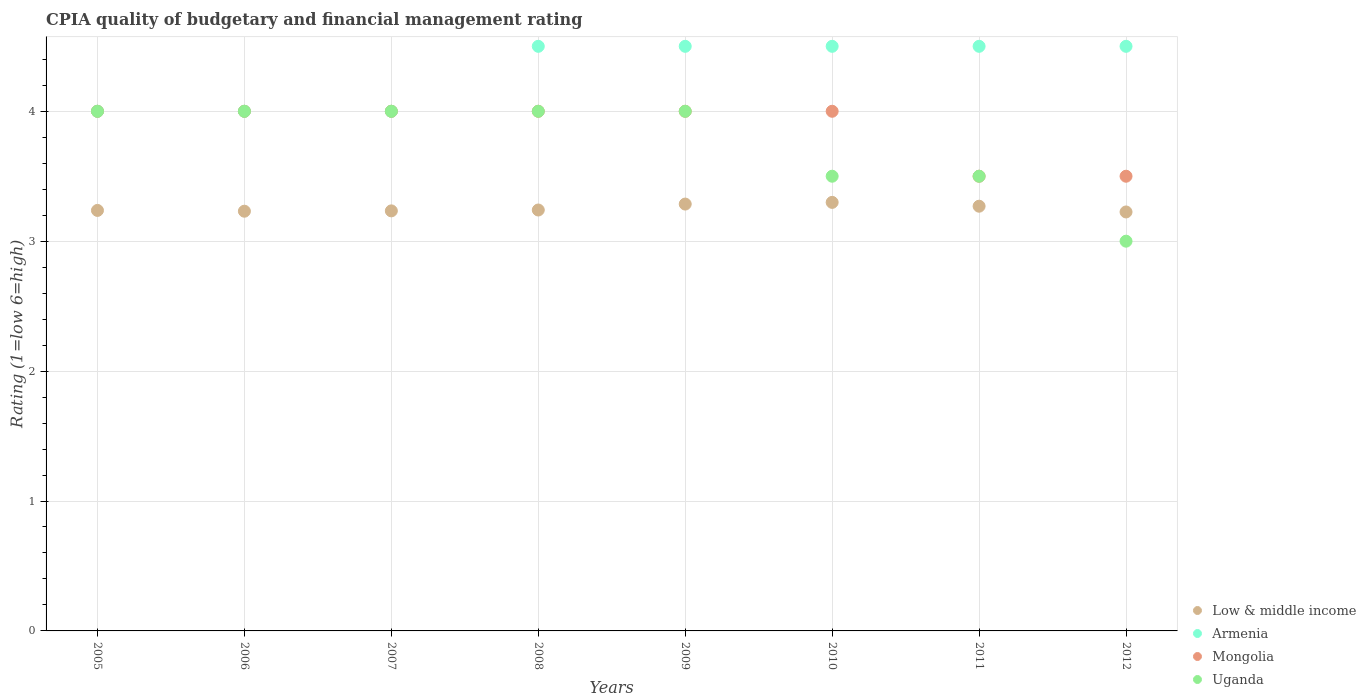What is the CPIA rating in Armenia in 2009?
Your response must be concise. 4.5. Across all years, what is the maximum CPIA rating in Armenia?
Your answer should be compact. 4.5. Across all years, what is the minimum CPIA rating in Armenia?
Offer a very short reply. 4. In which year was the CPIA rating in Armenia maximum?
Your response must be concise. 2008. What is the total CPIA rating in Low & middle income in the graph?
Your response must be concise. 26.02. What is the average CPIA rating in Armenia per year?
Give a very brief answer. 4.31. In the year 2009, what is the difference between the CPIA rating in Low & middle income and CPIA rating in Armenia?
Keep it short and to the point. -1.21. In how many years, is the CPIA rating in Low & middle income greater than 0.2?
Your response must be concise. 8. What is the ratio of the CPIA rating in Armenia in 2006 to that in 2009?
Provide a succinct answer. 0.89. Is the CPIA rating in Low & middle income in 2007 less than that in 2009?
Provide a short and direct response. Yes. What is the difference between the highest and the second highest CPIA rating in Armenia?
Give a very brief answer. 0. What is the difference between the highest and the lowest CPIA rating in Uganda?
Provide a short and direct response. 1. Is the sum of the CPIA rating in Mongolia in 2005 and 2006 greater than the maximum CPIA rating in Low & middle income across all years?
Offer a very short reply. Yes. Is the CPIA rating in Uganda strictly greater than the CPIA rating in Low & middle income over the years?
Provide a short and direct response. No. How many dotlines are there?
Keep it short and to the point. 4. What is the difference between two consecutive major ticks on the Y-axis?
Provide a short and direct response. 1. How are the legend labels stacked?
Your response must be concise. Vertical. What is the title of the graph?
Offer a very short reply. CPIA quality of budgetary and financial management rating. Does "Guinea" appear as one of the legend labels in the graph?
Your response must be concise. No. What is the label or title of the Y-axis?
Ensure brevity in your answer.  Rating (1=low 6=high). What is the Rating (1=low 6=high) of Low & middle income in 2005?
Make the answer very short. 3.24. What is the Rating (1=low 6=high) of Armenia in 2005?
Provide a short and direct response. 4. What is the Rating (1=low 6=high) in Mongolia in 2005?
Offer a very short reply. 4. What is the Rating (1=low 6=high) in Low & middle income in 2006?
Provide a short and direct response. 3.23. What is the Rating (1=low 6=high) in Low & middle income in 2007?
Offer a terse response. 3.23. What is the Rating (1=low 6=high) in Uganda in 2007?
Provide a succinct answer. 4. What is the Rating (1=low 6=high) of Low & middle income in 2008?
Give a very brief answer. 3.24. What is the Rating (1=low 6=high) in Low & middle income in 2009?
Offer a terse response. 3.29. What is the Rating (1=low 6=high) in Low & middle income in 2010?
Make the answer very short. 3.3. What is the Rating (1=low 6=high) in Low & middle income in 2011?
Your response must be concise. 3.27. What is the Rating (1=low 6=high) in Low & middle income in 2012?
Provide a short and direct response. 3.23. What is the Rating (1=low 6=high) in Armenia in 2012?
Ensure brevity in your answer.  4.5. What is the Rating (1=low 6=high) in Mongolia in 2012?
Ensure brevity in your answer.  3.5. Across all years, what is the maximum Rating (1=low 6=high) in Low & middle income?
Provide a short and direct response. 3.3. Across all years, what is the maximum Rating (1=low 6=high) of Armenia?
Ensure brevity in your answer.  4.5. Across all years, what is the minimum Rating (1=low 6=high) in Low & middle income?
Your response must be concise. 3.23. Across all years, what is the minimum Rating (1=low 6=high) of Armenia?
Provide a succinct answer. 4. Across all years, what is the minimum Rating (1=low 6=high) in Mongolia?
Provide a succinct answer. 3.5. Across all years, what is the minimum Rating (1=low 6=high) of Uganda?
Your answer should be compact. 3. What is the total Rating (1=low 6=high) in Low & middle income in the graph?
Keep it short and to the point. 26.02. What is the total Rating (1=low 6=high) of Armenia in the graph?
Make the answer very short. 34.5. What is the difference between the Rating (1=low 6=high) in Low & middle income in 2005 and that in 2006?
Your response must be concise. 0.01. What is the difference between the Rating (1=low 6=high) of Armenia in 2005 and that in 2006?
Make the answer very short. 0. What is the difference between the Rating (1=low 6=high) in Low & middle income in 2005 and that in 2007?
Make the answer very short. 0. What is the difference between the Rating (1=low 6=high) of Armenia in 2005 and that in 2007?
Provide a short and direct response. 0. What is the difference between the Rating (1=low 6=high) in Low & middle income in 2005 and that in 2008?
Keep it short and to the point. -0. What is the difference between the Rating (1=low 6=high) in Armenia in 2005 and that in 2008?
Provide a succinct answer. -0.5. What is the difference between the Rating (1=low 6=high) of Uganda in 2005 and that in 2008?
Make the answer very short. 0. What is the difference between the Rating (1=low 6=high) in Low & middle income in 2005 and that in 2009?
Keep it short and to the point. -0.05. What is the difference between the Rating (1=low 6=high) of Armenia in 2005 and that in 2009?
Provide a short and direct response. -0.5. What is the difference between the Rating (1=low 6=high) of Low & middle income in 2005 and that in 2010?
Ensure brevity in your answer.  -0.06. What is the difference between the Rating (1=low 6=high) of Low & middle income in 2005 and that in 2011?
Your answer should be very brief. -0.03. What is the difference between the Rating (1=low 6=high) in Low & middle income in 2005 and that in 2012?
Offer a terse response. 0.01. What is the difference between the Rating (1=low 6=high) of Mongolia in 2005 and that in 2012?
Your answer should be very brief. 0.5. What is the difference between the Rating (1=low 6=high) of Uganda in 2005 and that in 2012?
Your answer should be very brief. 1. What is the difference between the Rating (1=low 6=high) in Low & middle income in 2006 and that in 2007?
Your response must be concise. -0. What is the difference between the Rating (1=low 6=high) in Armenia in 2006 and that in 2007?
Make the answer very short. 0. What is the difference between the Rating (1=low 6=high) in Low & middle income in 2006 and that in 2008?
Provide a short and direct response. -0.01. What is the difference between the Rating (1=low 6=high) of Uganda in 2006 and that in 2008?
Offer a very short reply. 0. What is the difference between the Rating (1=low 6=high) of Low & middle income in 2006 and that in 2009?
Give a very brief answer. -0.05. What is the difference between the Rating (1=low 6=high) in Mongolia in 2006 and that in 2009?
Make the answer very short. 0. What is the difference between the Rating (1=low 6=high) in Uganda in 2006 and that in 2009?
Offer a very short reply. 0. What is the difference between the Rating (1=low 6=high) in Low & middle income in 2006 and that in 2010?
Your response must be concise. -0.07. What is the difference between the Rating (1=low 6=high) of Low & middle income in 2006 and that in 2011?
Provide a succinct answer. -0.04. What is the difference between the Rating (1=low 6=high) in Armenia in 2006 and that in 2011?
Keep it short and to the point. -0.5. What is the difference between the Rating (1=low 6=high) of Mongolia in 2006 and that in 2011?
Keep it short and to the point. 0.5. What is the difference between the Rating (1=low 6=high) in Uganda in 2006 and that in 2011?
Your answer should be compact. 0.5. What is the difference between the Rating (1=low 6=high) in Low & middle income in 2006 and that in 2012?
Provide a short and direct response. 0.01. What is the difference between the Rating (1=low 6=high) of Uganda in 2006 and that in 2012?
Make the answer very short. 1. What is the difference between the Rating (1=low 6=high) in Low & middle income in 2007 and that in 2008?
Make the answer very short. -0.01. What is the difference between the Rating (1=low 6=high) in Armenia in 2007 and that in 2008?
Keep it short and to the point. -0.5. What is the difference between the Rating (1=low 6=high) in Mongolia in 2007 and that in 2008?
Your answer should be very brief. 0. What is the difference between the Rating (1=low 6=high) of Uganda in 2007 and that in 2008?
Offer a terse response. 0. What is the difference between the Rating (1=low 6=high) of Low & middle income in 2007 and that in 2009?
Your response must be concise. -0.05. What is the difference between the Rating (1=low 6=high) in Low & middle income in 2007 and that in 2010?
Provide a short and direct response. -0.07. What is the difference between the Rating (1=low 6=high) of Armenia in 2007 and that in 2010?
Your answer should be very brief. -0.5. What is the difference between the Rating (1=low 6=high) of Mongolia in 2007 and that in 2010?
Your answer should be very brief. 0. What is the difference between the Rating (1=low 6=high) of Uganda in 2007 and that in 2010?
Your answer should be compact. 0.5. What is the difference between the Rating (1=low 6=high) of Low & middle income in 2007 and that in 2011?
Ensure brevity in your answer.  -0.04. What is the difference between the Rating (1=low 6=high) in Armenia in 2007 and that in 2011?
Your response must be concise. -0.5. What is the difference between the Rating (1=low 6=high) in Uganda in 2007 and that in 2011?
Your response must be concise. 0.5. What is the difference between the Rating (1=low 6=high) in Low & middle income in 2007 and that in 2012?
Your answer should be compact. 0.01. What is the difference between the Rating (1=low 6=high) in Uganda in 2007 and that in 2012?
Keep it short and to the point. 1. What is the difference between the Rating (1=low 6=high) of Low & middle income in 2008 and that in 2009?
Keep it short and to the point. -0.05. What is the difference between the Rating (1=low 6=high) in Low & middle income in 2008 and that in 2010?
Your answer should be compact. -0.06. What is the difference between the Rating (1=low 6=high) in Uganda in 2008 and that in 2010?
Make the answer very short. 0.5. What is the difference between the Rating (1=low 6=high) of Low & middle income in 2008 and that in 2011?
Ensure brevity in your answer.  -0.03. What is the difference between the Rating (1=low 6=high) in Armenia in 2008 and that in 2011?
Provide a short and direct response. 0. What is the difference between the Rating (1=low 6=high) in Uganda in 2008 and that in 2011?
Your answer should be very brief. 0.5. What is the difference between the Rating (1=low 6=high) of Low & middle income in 2008 and that in 2012?
Offer a terse response. 0.01. What is the difference between the Rating (1=low 6=high) of Mongolia in 2008 and that in 2012?
Ensure brevity in your answer.  0.5. What is the difference between the Rating (1=low 6=high) in Uganda in 2008 and that in 2012?
Your answer should be very brief. 1. What is the difference between the Rating (1=low 6=high) of Low & middle income in 2009 and that in 2010?
Provide a succinct answer. -0.01. What is the difference between the Rating (1=low 6=high) in Armenia in 2009 and that in 2010?
Your answer should be compact. 0. What is the difference between the Rating (1=low 6=high) of Low & middle income in 2009 and that in 2011?
Your answer should be very brief. 0.02. What is the difference between the Rating (1=low 6=high) in Armenia in 2009 and that in 2011?
Provide a short and direct response. 0. What is the difference between the Rating (1=low 6=high) of Uganda in 2009 and that in 2011?
Ensure brevity in your answer.  0.5. What is the difference between the Rating (1=low 6=high) in Low & middle income in 2009 and that in 2012?
Give a very brief answer. 0.06. What is the difference between the Rating (1=low 6=high) of Armenia in 2009 and that in 2012?
Make the answer very short. 0. What is the difference between the Rating (1=low 6=high) in Uganda in 2009 and that in 2012?
Provide a succinct answer. 1. What is the difference between the Rating (1=low 6=high) of Low & middle income in 2010 and that in 2011?
Make the answer very short. 0.03. What is the difference between the Rating (1=low 6=high) of Mongolia in 2010 and that in 2011?
Give a very brief answer. 0.5. What is the difference between the Rating (1=low 6=high) in Low & middle income in 2010 and that in 2012?
Make the answer very short. 0.07. What is the difference between the Rating (1=low 6=high) of Armenia in 2010 and that in 2012?
Provide a short and direct response. 0. What is the difference between the Rating (1=low 6=high) in Low & middle income in 2011 and that in 2012?
Give a very brief answer. 0.04. What is the difference between the Rating (1=low 6=high) in Armenia in 2011 and that in 2012?
Your response must be concise. 0. What is the difference between the Rating (1=low 6=high) in Mongolia in 2011 and that in 2012?
Provide a succinct answer. 0. What is the difference between the Rating (1=low 6=high) of Low & middle income in 2005 and the Rating (1=low 6=high) of Armenia in 2006?
Provide a succinct answer. -0.76. What is the difference between the Rating (1=low 6=high) of Low & middle income in 2005 and the Rating (1=low 6=high) of Mongolia in 2006?
Keep it short and to the point. -0.76. What is the difference between the Rating (1=low 6=high) in Low & middle income in 2005 and the Rating (1=low 6=high) in Uganda in 2006?
Offer a terse response. -0.76. What is the difference between the Rating (1=low 6=high) of Armenia in 2005 and the Rating (1=low 6=high) of Mongolia in 2006?
Your response must be concise. 0. What is the difference between the Rating (1=low 6=high) in Low & middle income in 2005 and the Rating (1=low 6=high) in Armenia in 2007?
Provide a succinct answer. -0.76. What is the difference between the Rating (1=low 6=high) of Low & middle income in 2005 and the Rating (1=low 6=high) of Mongolia in 2007?
Provide a succinct answer. -0.76. What is the difference between the Rating (1=low 6=high) of Low & middle income in 2005 and the Rating (1=low 6=high) of Uganda in 2007?
Your response must be concise. -0.76. What is the difference between the Rating (1=low 6=high) of Low & middle income in 2005 and the Rating (1=low 6=high) of Armenia in 2008?
Your answer should be very brief. -1.26. What is the difference between the Rating (1=low 6=high) in Low & middle income in 2005 and the Rating (1=low 6=high) in Mongolia in 2008?
Offer a very short reply. -0.76. What is the difference between the Rating (1=low 6=high) of Low & middle income in 2005 and the Rating (1=low 6=high) of Uganda in 2008?
Provide a short and direct response. -0.76. What is the difference between the Rating (1=low 6=high) of Mongolia in 2005 and the Rating (1=low 6=high) of Uganda in 2008?
Offer a very short reply. 0. What is the difference between the Rating (1=low 6=high) of Low & middle income in 2005 and the Rating (1=low 6=high) of Armenia in 2009?
Keep it short and to the point. -1.26. What is the difference between the Rating (1=low 6=high) of Low & middle income in 2005 and the Rating (1=low 6=high) of Mongolia in 2009?
Your answer should be very brief. -0.76. What is the difference between the Rating (1=low 6=high) in Low & middle income in 2005 and the Rating (1=low 6=high) in Uganda in 2009?
Offer a very short reply. -0.76. What is the difference between the Rating (1=low 6=high) in Armenia in 2005 and the Rating (1=low 6=high) in Mongolia in 2009?
Your answer should be very brief. 0. What is the difference between the Rating (1=low 6=high) in Low & middle income in 2005 and the Rating (1=low 6=high) in Armenia in 2010?
Give a very brief answer. -1.26. What is the difference between the Rating (1=low 6=high) of Low & middle income in 2005 and the Rating (1=low 6=high) of Mongolia in 2010?
Your answer should be compact. -0.76. What is the difference between the Rating (1=low 6=high) of Low & middle income in 2005 and the Rating (1=low 6=high) of Uganda in 2010?
Provide a succinct answer. -0.26. What is the difference between the Rating (1=low 6=high) of Mongolia in 2005 and the Rating (1=low 6=high) of Uganda in 2010?
Offer a terse response. 0.5. What is the difference between the Rating (1=low 6=high) of Low & middle income in 2005 and the Rating (1=low 6=high) of Armenia in 2011?
Provide a succinct answer. -1.26. What is the difference between the Rating (1=low 6=high) in Low & middle income in 2005 and the Rating (1=low 6=high) in Mongolia in 2011?
Keep it short and to the point. -0.26. What is the difference between the Rating (1=low 6=high) of Low & middle income in 2005 and the Rating (1=low 6=high) of Uganda in 2011?
Your answer should be compact. -0.26. What is the difference between the Rating (1=low 6=high) in Mongolia in 2005 and the Rating (1=low 6=high) in Uganda in 2011?
Your answer should be very brief. 0.5. What is the difference between the Rating (1=low 6=high) in Low & middle income in 2005 and the Rating (1=low 6=high) in Armenia in 2012?
Your answer should be very brief. -1.26. What is the difference between the Rating (1=low 6=high) of Low & middle income in 2005 and the Rating (1=low 6=high) of Mongolia in 2012?
Offer a very short reply. -0.26. What is the difference between the Rating (1=low 6=high) of Low & middle income in 2005 and the Rating (1=low 6=high) of Uganda in 2012?
Ensure brevity in your answer.  0.24. What is the difference between the Rating (1=low 6=high) of Armenia in 2005 and the Rating (1=low 6=high) of Mongolia in 2012?
Make the answer very short. 0.5. What is the difference between the Rating (1=low 6=high) of Low & middle income in 2006 and the Rating (1=low 6=high) of Armenia in 2007?
Provide a short and direct response. -0.77. What is the difference between the Rating (1=low 6=high) of Low & middle income in 2006 and the Rating (1=low 6=high) of Mongolia in 2007?
Provide a short and direct response. -0.77. What is the difference between the Rating (1=low 6=high) of Low & middle income in 2006 and the Rating (1=low 6=high) of Uganda in 2007?
Your answer should be compact. -0.77. What is the difference between the Rating (1=low 6=high) of Mongolia in 2006 and the Rating (1=low 6=high) of Uganda in 2007?
Keep it short and to the point. 0. What is the difference between the Rating (1=low 6=high) of Low & middle income in 2006 and the Rating (1=low 6=high) of Armenia in 2008?
Ensure brevity in your answer.  -1.27. What is the difference between the Rating (1=low 6=high) of Low & middle income in 2006 and the Rating (1=low 6=high) of Mongolia in 2008?
Give a very brief answer. -0.77. What is the difference between the Rating (1=low 6=high) in Low & middle income in 2006 and the Rating (1=low 6=high) in Uganda in 2008?
Your answer should be very brief. -0.77. What is the difference between the Rating (1=low 6=high) in Mongolia in 2006 and the Rating (1=low 6=high) in Uganda in 2008?
Provide a succinct answer. 0. What is the difference between the Rating (1=low 6=high) in Low & middle income in 2006 and the Rating (1=low 6=high) in Armenia in 2009?
Give a very brief answer. -1.27. What is the difference between the Rating (1=low 6=high) in Low & middle income in 2006 and the Rating (1=low 6=high) in Mongolia in 2009?
Offer a very short reply. -0.77. What is the difference between the Rating (1=low 6=high) of Low & middle income in 2006 and the Rating (1=low 6=high) of Uganda in 2009?
Your answer should be compact. -0.77. What is the difference between the Rating (1=low 6=high) in Armenia in 2006 and the Rating (1=low 6=high) in Uganda in 2009?
Your answer should be compact. 0. What is the difference between the Rating (1=low 6=high) of Low & middle income in 2006 and the Rating (1=low 6=high) of Armenia in 2010?
Offer a terse response. -1.27. What is the difference between the Rating (1=low 6=high) in Low & middle income in 2006 and the Rating (1=low 6=high) in Mongolia in 2010?
Keep it short and to the point. -0.77. What is the difference between the Rating (1=low 6=high) in Low & middle income in 2006 and the Rating (1=low 6=high) in Uganda in 2010?
Ensure brevity in your answer.  -0.27. What is the difference between the Rating (1=low 6=high) in Armenia in 2006 and the Rating (1=low 6=high) in Uganda in 2010?
Give a very brief answer. 0.5. What is the difference between the Rating (1=low 6=high) of Mongolia in 2006 and the Rating (1=low 6=high) of Uganda in 2010?
Your answer should be very brief. 0.5. What is the difference between the Rating (1=low 6=high) in Low & middle income in 2006 and the Rating (1=low 6=high) in Armenia in 2011?
Ensure brevity in your answer.  -1.27. What is the difference between the Rating (1=low 6=high) of Low & middle income in 2006 and the Rating (1=low 6=high) of Mongolia in 2011?
Offer a very short reply. -0.27. What is the difference between the Rating (1=low 6=high) in Low & middle income in 2006 and the Rating (1=low 6=high) in Uganda in 2011?
Provide a succinct answer. -0.27. What is the difference between the Rating (1=low 6=high) of Mongolia in 2006 and the Rating (1=low 6=high) of Uganda in 2011?
Ensure brevity in your answer.  0.5. What is the difference between the Rating (1=low 6=high) of Low & middle income in 2006 and the Rating (1=low 6=high) of Armenia in 2012?
Provide a short and direct response. -1.27. What is the difference between the Rating (1=low 6=high) of Low & middle income in 2006 and the Rating (1=low 6=high) of Mongolia in 2012?
Give a very brief answer. -0.27. What is the difference between the Rating (1=low 6=high) of Low & middle income in 2006 and the Rating (1=low 6=high) of Uganda in 2012?
Your response must be concise. 0.23. What is the difference between the Rating (1=low 6=high) in Low & middle income in 2007 and the Rating (1=low 6=high) in Armenia in 2008?
Give a very brief answer. -1.27. What is the difference between the Rating (1=low 6=high) of Low & middle income in 2007 and the Rating (1=low 6=high) of Mongolia in 2008?
Your response must be concise. -0.77. What is the difference between the Rating (1=low 6=high) in Low & middle income in 2007 and the Rating (1=low 6=high) in Uganda in 2008?
Offer a very short reply. -0.77. What is the difference between the Rating (1=low 6=high) of Low & middle income in 2007 and the Rating (1=low 6=high) of Armenia in 2009?
Provide a short and direct response. -1.27. What is the difference between the Rating (1=low 6=high) of Low & middle income in 2007 and the Rating (1=low 6=high) of Mongolia in 2009?
Offer a very short reply. -0.77. What is the difference between the Rating (1=low 6=high) in Low & middle income in 2007 and the Rating (1=low 6=high) in Uganda in 2009?
Your answer should be very brief. -0.77. What is the difference between the Rating (1=low 6=high) of Armenia in 2007 and the Rating (1=low 6=high) of Mongolia in 2009?
Make the answer very short. 0. What is the difference between the Rating (1=low 6=high) of Armenia in 2007 and the Rating (1=low 6=high) of Uganda in 2009?
Keep it short and to the point. 0. What is the difference between the Rating (1=low 6=high) in Mongolia in 2007 and the Rating (1=low 6=high) in Uganda in 2009?
Make the answer very short. 0. What is the difference between the Rating (1=low 6=high) in Low & middle income in 2007 and the Rating (1=low 6=high) in Armenia in 2010?
Ensure brevity in your answer.  -1.27. What is the difference between the Rating (1=low 6=high) of Low & middle income in 2007 and the Rating (1=low 6=high) of Mongolia in 2010?
Your answer should be compact. -0.77. What is the difference between the Rating (1=low 6=high) in Low & middle income in 2007 and the Rating (1=low 6=high) in Uganda in 2010?
Your response must be concise. -0.27. What is the difference between the Rating (1=low 6=high) in Armenia in 2007 and the Rating (1=low 6=high) in Mongolia in 2010?
Give a very brief answer. 0. What is the difference between the Rating (1=low 6=high) in Armenia in 2007 and the Rating (1=low 6=high) in Uganda in 2010?
Make the answer very short. 0.5. What is the difference between the Rating (1=low 6=high) of Mongolia in 2007 and the Rating (1=low 6=high) of Uganda in 2010?
Offer a terse response. 0.5. What is the difference between the Rating (1=low 6=high) of Low & middle income in 2007 and the Rating (1=low 6=high) of Armenia in 2011?
Make the answer very short. -1.27. What is the difference between the Rating (1=low 6=high) of Low & middle income in 2007 and the Rating (1=low 6=high) of Mongolia in 2011?
Provide a succinct answer. -0.27. What is the difference between the Rating (1=low 6=high) in Low & middle income in 2007 and the Rating (1=low 6=high) in Uganda in 2011?
Provide a short and direct response. -0.27. What is the difference between the Rating (1=low 6=high) of Armenia in 2007 and the Rating (1=low 6=high) of Mongolia in 2011?
Offer a very short reply. 0.5. What is the difference between the Rating (1=low 6=high) of Mongolia in 2007 and the Rating (1=low 6=high) of Uganda in 2011?
Keep it short and to the point. 0.5. What is the difference between the Rating (1=low 6=high) in Low & middle income in 2007 and the Rating (1=low 6=high) in Armenia in 2012?
Offer a terse response. -1.27. What is the difference between the Rating (1=low 6=high) of Low & middle income in 2007 and the Rating (1=low 6=high) of Mongolia in 2012?
Keep it short and to the point. -0.27. What is the difference between the Rating (1=low 6=high) in Low & middle income in 2007 and the Rating (1=low 6=high) in Uganda in 2012?
Your response must be concise. 0.23. What is the difference between the Rating (1=low 6=high) in Armenia in 2007 and the Rating (1=low 6=high) in Uganda in 2012?
Your answer should be compact. 1. What is the difference between the Rating (1=low 6=high) of Low & middle income in 2008 and the Rating (1=low 6=high) of Armenia in 2009?
Your response must be concise. -1.26. What is the difference between the Rating (1=low 6=high) of Low & middle income in 2008 and the Rating (1=low 6=high) of Mongolia in 2009?
Provide a short and direct response. -0.76. What is the difference between the Rating (1=low 6=high) of Low & middle income in 2008 and the Rating (1=low 6=high) of Uganda in 2009?
Offer a very short reply. -0.76. What is the difference between the Rating (1=low 6=high) in Low & middle income in 2008 and the Rating (1=low 6=high) in Armenia in 2010?
Offer a very short reply. -1.26. What is the difference between the Rating (1=low 6=high) in Low & middle income in 2008 and the Rating (1=low 6=high) in Mongolia in 2010?
Ensure brevity in your answer.  -0.76. What is the difference between the Rating (1=low 6=high) in Low & middle income in 2008 and the Rating (1=low 6=high) in Uganda in 2010?
Make the answer very short. -0.26. What is the difference between the Rating (1=low 6=high) in Armenia in 2008 and the Rating (1=low 6=high) in Mongolia in 2010?
Your response must be concise. 0.5. What is the difference between the Rating (1=low 6=high) of Low & middle income in 2008 and the Rating (1=low 6=high) of Armenia in 2011?
Keep it short and to the point. -1.26. What is the difference between the Rating (1=low 6=high) of Low & middle income in 2008 and the Rating (1=low 6=high) of Mongolia in 2011?
Provide a succinct answer. -0.26. What is the difference between the Rating (1=low 6=high) in Low & middle income in 2008 and the Rating (1=low 6=high) in Uganda in 2011?
Offer a terse response. -0.26. What is the difference between the Rating (1=low 6=high) of Mongolia in 2008 and the Rating (1=low 6=high) of Uganda in 2011?
Ensure brevity in your answer.  0.5. What is the difference between the Rating (1=low 6=high) in Low & middle income in 2008 and the Rating (1=low 6=high) in Armenia in 2012?
Make the answer very short. -1.26. What is the difference between the Rating (1=low 6=high) in Low & middle income in 2008 and the Rating (1=low 6=high) in Mongolia in 2012?
Provide a short and direct response. -0.26. What is the difference between the Rating (1=low 6=high) of Low & middle income in 2008 and the Rating (1=low 6=high) of Uganda in 2012?
Provide a succinct answer. 0.24. What is the difference between the Rating (1=low 6=high) of Mongolia in 2008 and the Rating (1=low 6=high) of Uganda in 2012?
Offer a terse response. 1. What is the difference between the Rating (1=low 6=high) of Low & middle income in 2009 and the Rating (1=low 6=high) of Armenia in 2010?
Ensure brevity in your answer.  -1.21. What is the difference between the Rating (1=low 6=high) in Low & middle income in 2009 and the Rating (1=low 6=high) in Mongolia in 2010?
Your response must be concise. -0.71. What is the difference between the Rating (1=low 6=high) in Low & middle income in 2009 and the Rating (1=low 6=high) in Uganda in 2010?
Offer a terse response. -0.21. What is the difference between the Rating (1=low 6=high) in Armenia in 2009 and the Rating (1=low 6=high) in Mongolia in 2010?
Give a very brief answer. 0.5. What is the difference between the Rating (1=low 6=high) in Armenia in 2009 and the Rating (1=low 6=high) in Uganda in 2010?
Provide a short and direct response. 1. What is the difference between the Rating (1=low 6=high) of Low & middle income in 2009 and the Rating (1=low 6=high) of Armenia in 2011?
Your answer should be very brief. -1.21. What is the difference between the Rating (1=low 6=high) of Low & middle income in 2009 and the Rating (1=low 6=high) of Mongolia in 2011?
Provide a short and direct response. -0.21. What is the difference between the Rating (1=low 6=high) of Low & middle income in 2009 and the Rating (1=low 6=high) of Uganda in 2011?
Keep it short and to the point. -0.21. What is the difference between the Rating (1=low 6=high) of Low & middle income in 2009 and the Rating (1=low 6=high) of Armenia in 2012?
Keep it short and to the point. -1.21. What is the difference between the Rating (1=low 6=high) in Low & middle income in 2009 and the Rating (1=low 6=high) in Mongolia in 2012?
Offer a terse response. -0.21. What is the difference between the Rating (1=low 6=high) of Low & middle income in 2009 and the Rating (1=low 6=high) of Uganda in 2012?
Provide a short and direct response. 0.29. What is the difference between the Rating (1=low 6=high) of Armenia in 2009 and the Rating (1=low 6=high) of Mongolia in 2012?
Your answer should be very brief. 1. What is the difference between the Rating (1=low 6=high) of Low & middle income in 2010 and the Rating (1=low 6=high) of Armenia in 2011?
Offer a terse response. -1.2. What is the difference between the Rating (1=low 6=high) in Low & middle income in 2010 and the Rating (1=low 6=high) in Mongolia in 2011?
Give a very brief answer. -0.2. What is the difference between the Rating (1=low 6=high) of Low & middle income in 2010 and the Rating (1=low 6=high) of Uganda in 2011?
Offer a terse response. -0.2. What is the difference between the Rating (1=low 6=high) in Armenia in 2010 and the Rating (1=low 6=high) in Mongolia in 2011?
Provide a short and direct response. 1. What is the difference between the Rating (1=low 6=high) of Armenia in 2010 and the Rating (1=low 6=high) of Uganda in 2011?
Keep it short and to the point. 1. What is the difference between the Rating (1=low 6=high) of Low & middle income in 2010 and the Rating (1=low 6=high) of Armenia in 2012?
Provide a succinct answer. -1.2. What is the difference between the Rating (1=low 6=high) in Low & middle income in 2010 and the Rating (1=low 6=high) in Mongolia in 2012?
Provide a short and direct response. -0.2. What is the difference between the Rating (1=low 6=high) in Low & middle income in 2010 and the Rating (1=low 6=high) in Uganda in 2012?
Your answer should be compact. 0.3. What is the difference between the Rating (1=low 6=high) in Armenia in 2010 and the Rating (1=low 6=high) in Mongolia in 2012?
Your response must be concise. 1. What is the difference between the Rating (1=low 6=high) of Mongolia in 2010 and the Rating (1=low 6=high) of Uganda in 2012?
Give a very brief answer. 1. What is the difference between the Rating (1=low 6=high) of Low & middle income in 2011 and the Rating (1=low 6=high) of Armenia in 2012?
Provide a short and direct response. -1.23. What is the difference between the Rating (1=low 6=high) in Low & middle income in 2011 and the Rating (1=low 6=high) in Mongolia in 2012?
Your answer should be compact. -0.23. What is the difference between the Rating (1=low 6=high) of Low & middle income in 2011 and the Rating (1=low 6=high) of Uganda in 2012?
Provide a short and direct response. 0.27. What is the difference between the Rating (1=low 6=high) in Armenia in 2011 and the Rating (1=low 6=high) in Mongolia in 2012?
Your response must be concise. 1. What is the difference between the Rating (1=low 6=high) of Mongolia in 2011 and the Rating (1=low 6=high) of Uganda in 2012?
Keep it short and to the point. 0.5. What is the average Rating (1=low 6=high) in Low & middle income per year?
Your response must be concise. 3.25. What is the average Rating (1=low 6=high) of Armenia per year?
Your answer should be compact. 4.31. What is the average Rating (1=low 6=high) in Mongolia per year?
Keep it short and to the point. 3.88. What is the average Rating (1=low 6=high) in Uganda per year?
Offer a terse response. 3.75. In the year 2005, what is the difference between the Rating (1=low 6=high) of Low & middle income and Rating (1=low 6=high) of Armenia?
Offer a very short reply. -0.76. In the year 2005, what is the difference between the Rating (1=low 6=high) in Low & middle income and Rating (1=low 6=high) in Mongolia?
Offer a very short reply. -0.76. In the year 2005, what is the difference between the Rating (1=low 6=high) of Low & middle income and Rating (1=low 6=high) of Uganda?
Give a very brief answer. -0.76. In the year 2005, what is the difference between the Rating (1=low 6=high) of Armenia and Rating (1=low 6=high) of Mongolia?
Your answer should be very brief. 0. In the year 2006, what is the difference between the Rating (1=low 6=high) in Low & middle income and Rating (1=low 6=high) in Armenia?
Your answer should be very brief. -0.77. In the year 2006, what is the difference between the Rating (1=low 6=high) in Low & middle income and Rating (1=low 6=high) in Mongolia?
Offer a terse response. -0.77. In the year 2006, what is the difference between the Rating (1=low 6=high) in Low & middle income and Rating (1=low 6=high) in Uganda?
Your answer should be compact. -0.77. In the year 2006, what is the difference between the Rating (1=low 6=high) in Mongolia and Rating (1=low 6=high) in Uganda?
Make the answer very short. 0. In the year 2007, what is the difference between the Rating (1=low 6=high) of Low & middle income and Rating (1=low 6=high) of Armenia?
Your answer should be compact. -0.77. In the year 2007, what is the difference between the Rating (1=low 6=high) in Low & middle income and Rating (1=low 6=high) in Mongolia?
Provide a short and direct response. -0.77. In the year 2007, what is the difference between the Rating (1=low 6=high) of Low & middle income and Rating (1=low 6=high) of Uganda?
Offer a terse response. -0.77. In the year 2007, what is the difference between the Rating (1=low 6=high) of Armenia and Rating (1=low 6=high) of Mongolia?
Your answer should be compact. 0. In the year 2007, what is the difference between the Rating (1=low 6=high) in Armenia and Rating (1=low 6=high) in Uganda?
Keep it short and to the point. 0. In the year 2007, what is the difference between the Rating (1=low 6=high) of Mongolia and Rating (1=low 6=high) of Uganda?
Offer a terse response. 0. In the year 2008, what is the difference between the Rating (1=low 6=high) in Low & middle income and Rating (1=low 6=high) in Armenia?
Keep it short and to the point. -1.26. In the year 2008, what is the difference between the Rating (1=low 6=high) in Low & middle income and Rating (1=low 6=high) in Mongolia?
Give a very brief answer. -0.76. In the year 2008, what is the difference between the Rating (1=low 6=high) in Low & middle income and Rating (1=low 6=high) in Uganda?
Make the answer very short. -0.76. In the year 2008, what is the difference between the Rating (1=low 6=high) of Armenia and Rating (1=low 6=high) of Uganda?
Your answer should be very brief. 0.5. In the year 2009, what is the difference between the Rating (1=low 6=high) in Low & middle income and Rating (1=low 6=high) in Armenia?
Ensure brevity in your answer.  -1.21. In the year 2009, what is the difference between the Rating (1=low 6=high) of Low & middle income and Rating (1=low 6=high) of Mongolia?
Keep it short and to the point. -0.71. In the year 2009, what is the difference between the Rating (1=low 6=high) of Low & middle income and Rating (1=low 6=high) of Uganda?
Make the answer very short. -0.71. In the year 2009, what is the difference between the Rating (1=low 6=high) in Armenia and Rating (1=low 6=high) in Uganda?
Keep it short and to the point. 0.5. In the year 2009, what is the difference between the Rating (1=low 6=high) in Mongolia and Rating (1=low 6=high) in Uganda?
Offer a very short reply. 0. In the year 2010, what is the difference between the Rating (1=low 6=high) of Low & middle income and Rating (1=low 6=high) of Armenia?
Provide a succinct answer. -1.2. In the year 2010, what is the difference between the Rating (1=low 6=high) of Low & middle income and Rating (1=low 6=high) of Mongolia?
Make the answer very short. -0.7. In the year 2010, what is the difference between the Rating (1=low 6=high) in Low & middle income and Rating (1=low 6=high) in Uganda?
Your answer should be compact. -0.2. In the year 2010, what is the difference between the Rating (1=low 6=high) of Armenia and Rating (1=low 6=high) of Uganda?
Your answer should be very brief. 1. In the year 2010, what is the difference between the Rating (1=low 6=high) in Mongolia and Rating (1=low 6=high) in Uganda?
Give a very brief answer. 0.5. In the year 2011, what is the difference between the Rating (1=low 6=high) of Low & middle income and Rating (1=low 6=high) of Armenia?
Your answer should be compact. -1.23. In the year 2011, what is the difference between the Rating (1=low 6=high) in Low & middle income and Rating (1=low 6=high) in Mongolia?
Offer a very short reply. -0.23. In the year 2011, what is the difference between the Rating (1=low 6=high) of Low & middle income and Rating (1=low 6=high) of Uganda?
Give a very brief answer. -0.23. In the year 2012, what is the difference between the Rating (1=low 6=high) in Low & middle income and Rating (1=low 6=high) in Armenia?
Your answer should be compact. -1.27. In the year 2012, what is the difference between the Rating (1=low 6=high) of Low & middle income and Rating (1=low 6=high) of Mongolia?
Keep it short and to the point. -0.28. In the year 2012, what is the difference between the Rating (1=low 6=high) of Low & middle income and Rating (1=low 6=high) of Uganda?
Make the answer very short. 0.23. In the year 2012, what is the difference between the Rating (1=low 6=high) of Armenia and Rating (1=low 6=high) of Mongolia?
Provide a short and direct response. 1. In the year 2012, what is the difference between the Rating (1=low 6=high) of Armenia and Rating (1=low 6=high) of Uganda?
Provide a short and direct response. 1.5. What is the ratio of the Rating (1=low 6=high) of Armenia in 2005 to that in 2006?
Your answer should be very brief. 1. What is the ratio of the Rating (1=low 6=high) of Mongolia in 2005 to that in 2006?
Provide a short and direct response. 1. What is the ratio of the Rating (1=low 6=high) of Uganda in 2005 to that in 2006?
Your answer should be compact. 1. What is the ratio of the Rating (1=low 6=high) of Low & middle income in 2005 to that in 2007?
Make the answer very short. 1. What is the ratio of the Rating (1=low 6=high) in Mongolia in 2005 to that in 2007?
Provide a short and direct response. 1. What is the ratio of the Rating (1=low 6=high) of Low & middle income in 2005 to that in 2008?
Provide a short and direct response. 1. What is the ratio of the Rating (1=low 6=high) in Armenia in 2005 to that in 2008?
Make the answer very short. 0.89. What is the ratio of the Rating (1=low 6=high) of Mongolia in 2005 to that in 2008?
Provide a succinct answer. 1. What is the ratio of the Rating (1=low 6=high) in Uganda in 2005 to that in 2008?
Ensure brevity in your answer.  1. What is the ratio of the Rating (1=low 6=high) in Low & middle income in 2005 to that in 2009?
Offer a terse response. 0.99. What is the ratio of the Rating (1=low 6=high) of Low & middle income in 2005 to that in 2010?
Make the answer very short. 0.98. What is the ratio of the Rating (1=low 6=high) in Armenia in 2005 to that in 2010?
Offer a terse response. 0.89. What is the ratio of the Rating (1=low 6=high) in Mongolia in 2005 to that in 2010?
Make the answer very short. 1. What is the ratio of the Rating (1=low 6=high) in Low & middle income in 2005 to that in 2011?
Provide a succinct answer. 0.99. What is the ratio of the Rating (1=low 6=high) in Armenia in 2005 to that in 2011?
Your response must be concise. 0.89. What is the ratio of the Rating (1=low 6=high) of Uganda in 2005 to that in 2011?
Your answer should be very brief. 1.14. What is the ratio of the Rating (1=low 6=high) in Low & middle income in 2005 to that in 2012?
Make the answer very short. 1. What is the ratio of the Rating (1=low 6=high) in Mongolia in 2005 to that in 2012?
Provide a succinct answer. 1.14. What is the ratio of the Rating (1=low 6=high) in Low & middle income in 2006 to that in 2007?
Your answer should be very brief. 1. What is the ratio of the Rating (1=low 6=high) in Armenia in 2006 to that in 2007?
Your answer should be compact. 1. What is the ratio of the Rating (1=low 6=high) of Low & middle income in 2006 to that in 2008?
Give a very brief answer. 1. What is the ratio of the Rating (1=low 6=high) of Armenia in 2006 to that in 2008?
Keep it short and to the point. 0.89. What is the ratio of the Rating (1=low 6=high) in Uganda in 2006 to that in 2008?
Give a very brief answer. 1. What is the ratio of the Rating (1=low 6=high) in Low & middle income in 2006 to that in 2009?
Give a very brief answer. 0.98. What is the ratio of the Rating (1=low 6=high) in Uganda in 2006 to that in 2009?
Your answer should be compact. 1. What is the ratio of the Rating (1=low 6=high) in Low & middle income in 2006 to that in 2010?
Your response must be concise. 0.98. What is the ratio of the Rating (1=low 6=high) of Armenia in 2006 to that in 2011?
Ensure brevity in your answer.  0.89. What is the ratio of the Rating (1=low 6=high) of Mongolia in 2006 to that in 2011?
Offer a terse response. 1.14. What is the ratio of the Rating (1=low 6=high) of Uganda in 2006 to that in 2011?
Your response must be concise. 1.14. What is the ratio of the Rating (1=low 6=high) in Low & middle income in 2006 to that in 2012?
Provide a succinct answer. 1. What is the ratio of the Rating (1=low 6=high) of Low & middle income in 2007 to that in 2008?
Your answer should be very brief. 1. What is the ratio of the Rating (1=low 6=high) in Armenia in 2007 to that in 2008?
Your answer should be compact. 0.89. What is the ratio of the Rating (1=low 6=high) of Mongolia in 2007 to that in 2008?
Provide a short and direct response. 1. What is the ratio of the Rating (1=low 6=high) of Low & middle income in 2007 to that in 2009?
Your response must be concise. 0.98. What is the ratio of the Rating (1=low 6=high) of Armenia in 2007 to that in 2009?
Give a very brief answer. 0.89. What is the ratio of the Rating (1=low 6=high) of Mongolia in 2007 to that in 2009?
Give a very brief answer. 1. What is the ratio of the Rating (1=low 6=high) of Uganda in 2007 to that in 2009?
Provide a succinct answer. 1. What is the ratio of the Rating (1=low 6=high) in Low & middle income in 2007 to that in 2010?
Provide a succinct answer. 0.98. What is the ratio of the Rating (1=low 6=high) in Mongolia in 2007 to that in 2010?
Your answer should be compact. 1. What is the ratio of the Rating (1=low 6=high) in Uganda in 2007 to that in 2010?
Make the answer very short. 1.14. What is the ratio of the Rating (1=low 6=high) of Mongolia in 2007 to that in 2011?
Offer a terse response. 1.14. What is the ratio of the Rating (1=low 6=high) in Low & middle income in 2007 to that in 2012?
Provide a short and direct response. 1. What is the ratio of the Rating (1=low 6=high) of Armenia in 2007 to that in 2012?
Your answer should be compact. 0.89. What is the ratio of the Rating (1=low 6=high) in Low & middle income in 2008 to that in 2009?
Your answer should be very brief. 0.99. What is the ratio of the Rating (1=low 6=high) of Mongolia in 2008 to that in 2009?
Provide a succinct answer. 1. What is the ratio of the Rating (1=low 6=high) of Low & middle income in 2008 to that in 2010?
Ensure brevity in your answer.  0.98. What is the ratio of the Rating (1=low 6=high) of Armenia in 2008 to that in 2010?
Provide a succinct answer. 1. What is the ratio of the Rating (1=low 6=high) in Mongolia in 2008 to that in 2010?
Give a very brief answer. 1. What is the ratio of the Rating (1=low 6=high) in Armenia in 2008 to that in 2011?
Offer a terse response. 1. What is the ratio of the Rating (1=low 6=high) of Low & middle income in 2008 to that in 2012?
Ensure brevity in your answer.  1. What is the ratio of the Rating (1=low 6=high) of Armenia in 2008 to that in 2012?
Offer a very short reply. 1. What is the ratio of the Rating (1=low 6=high) in Low & middle income in 2009 to that in 2010?
Offer a very short reply. 1. What is the ratio of the Rating (1=low 6=high) of Mongolia in 2009 to that in 2010?
Your answer should be compact. 1. What is the ratio of the Rating (1=low 6=high) in Uganda in 2009 to that in 2010?
Your answer should be compact. 1.14. What is the ratio of the Rating (1=low 6=high) of Low & middle income in 2009 to that in 2011?
Make the answer very short. 1. What is the ratio of the Rating (1=low 6=high) of Armenia in 2009 to that in 2011?
Ensure brevity in your answer.  1. What is the ratio of the Rating (1=low 6=high) in Low & middle income in 2009 to that in 2012?
Ensure brevity in your answer.  1.02. What is the ratio of the Rating (1=low 6=high) in Mongolia in 2009 to that in 2012?
Offer a terse response. 1.14. What is the ratio of the Rating (1=low 6=high) of Uganda in 2009 to that in 2012?
Your answer should be very brief. 1.33. What is the ratio of the Rating (1=low 6=high) in Armenia in 2010 to that in 2011?
Ensure brevity in your answer.  1. What is the ratio of the Rating (1=low 6=high) in Uganda in 2010 to that in 2011?
Offer a terse response. 1. What is the ratio of the Rating (1=low 6=high) in Low & middle income in 2010 to that in 2012?
Offer a terse response. 1.02. What is the ratio of the Rating (1=low 6=high) in Armenia in 2010 to that in 2012?
Offer a very short reply. 1. What is the ratio of the Rating (1=low 6=high) in Low & middle income in 2011 to that in 2012?
Provide a succinct answer. 1.01. What is the ratio of the Rating (1=low 6=high) in Armenia in 2011 to that in 2012?
Provide a short and direct response. 1. What is the ratio of the Rating (1=low 6=high) of Uganda in 2011 to that in 2012?
Your response must be concise. 1.17. What is the difference between the highest and the second highest Rating (1=low 6=high) of Low & middle income?
Offer a terse response. 0.01. What is the difference between the highest and the lowest Rating (1=low 6=high) in Low & middle income?
Offer a terse response. 0.07. 